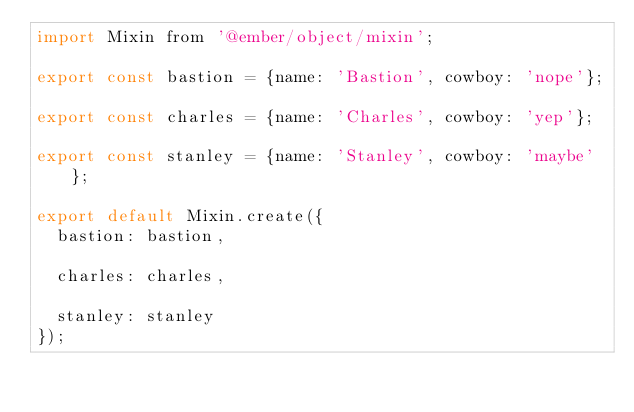Convert code to text. <code><loc_0><loc_0><loc_500><loc_500><_JavaScript_>import Mixin from '@ember/object/mixin';

export const bastion = {name: 'Bastion', cowboy: 'nope'};

export const charles = {name: 'Charles', cowboy: 'yep'};

export const stanley = {name: 'Stanley', cowboy: 'maybe'};

export default Mixin.create({
  bastion: bastion,

  charles: charles,

  stanley: stanley
});
</code> 